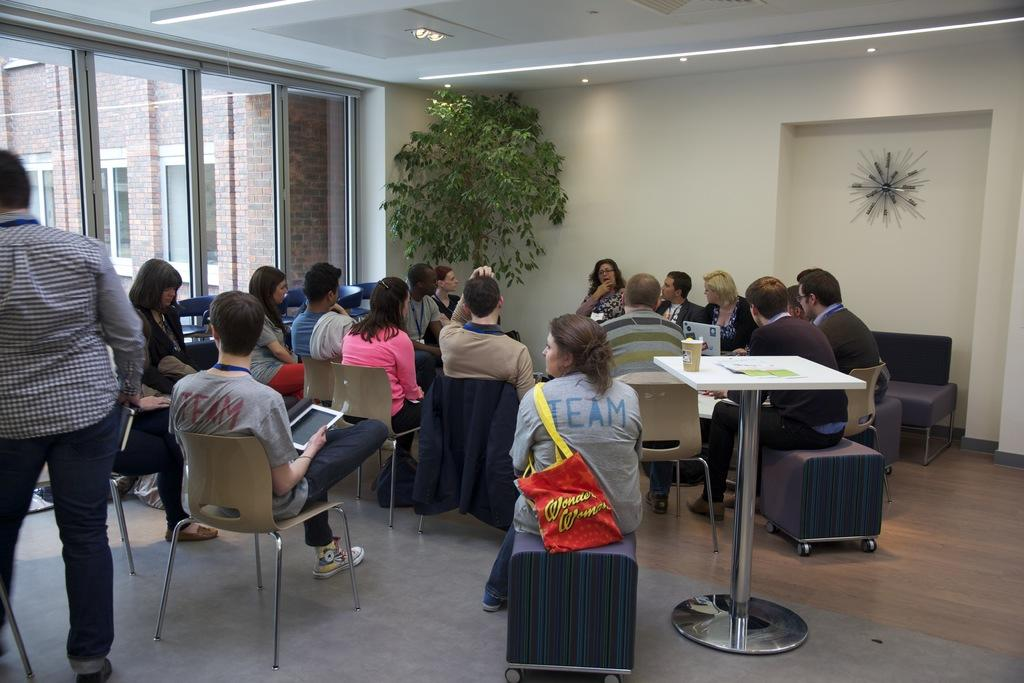What are the people in the image doing? The people in the image are sitting on chairs. What natural element can be seen in the image? There is a tree visible in the image. What is on the table in the image? There is a cup on a table in the image. What type of architectural feature is present in the image? There is a glass window in the image. What man-made structure is visible in the image? There is a building in the image. What is the rate of chin growth among the people in the image? There is no information about chin growth or rates in the image; it only shows people sitting on chairs, a tree, a cup on a table, a glass window, and a building. 